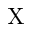<formula> <loc_0><loc_0><loc_500><loc_500>X</formula> 